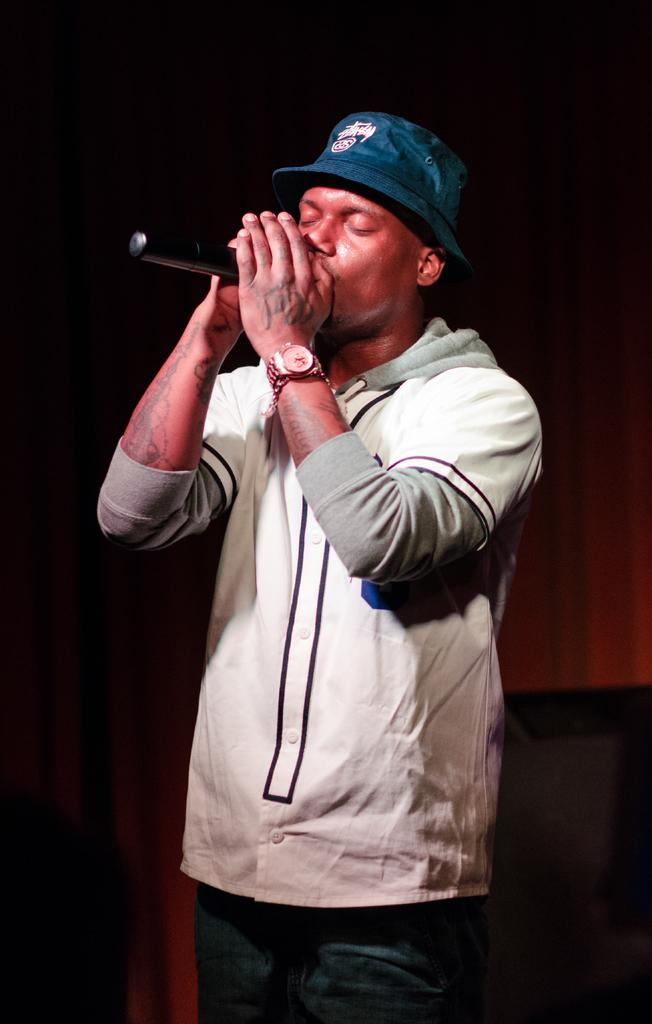What is the man in the image doing? The man is singing in the image. How is the man amplifying his voice while singing? The man is using a microphone in the image. How far away is the prison from the man in the image? There is no prison present in the image, so it is not possible to determine the distance between the man and a prison. 